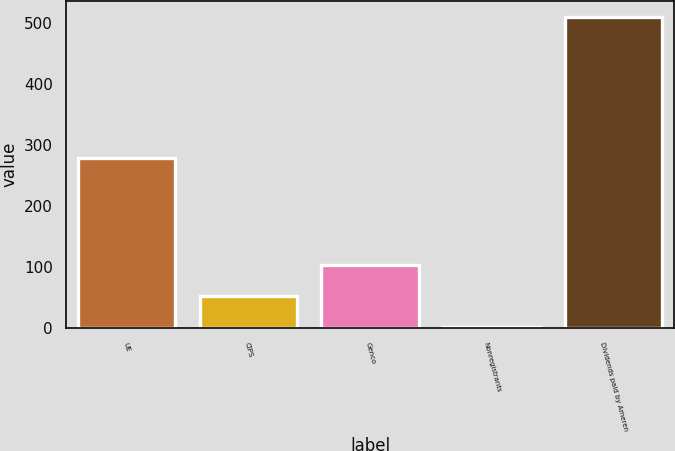Convert chart to OTSL. <chart><loc_0><loc_0><loc_500><loc_500><bar_chart><fcel>UE<fcel>CIPS<fcel>Genco<fcel>Nonregistrants<fcel>Dividends paid by Ameren<nl><fcel>280<fcel>52.9<fcel>103.8<fcel>2<fcel>511<nl></chart> 